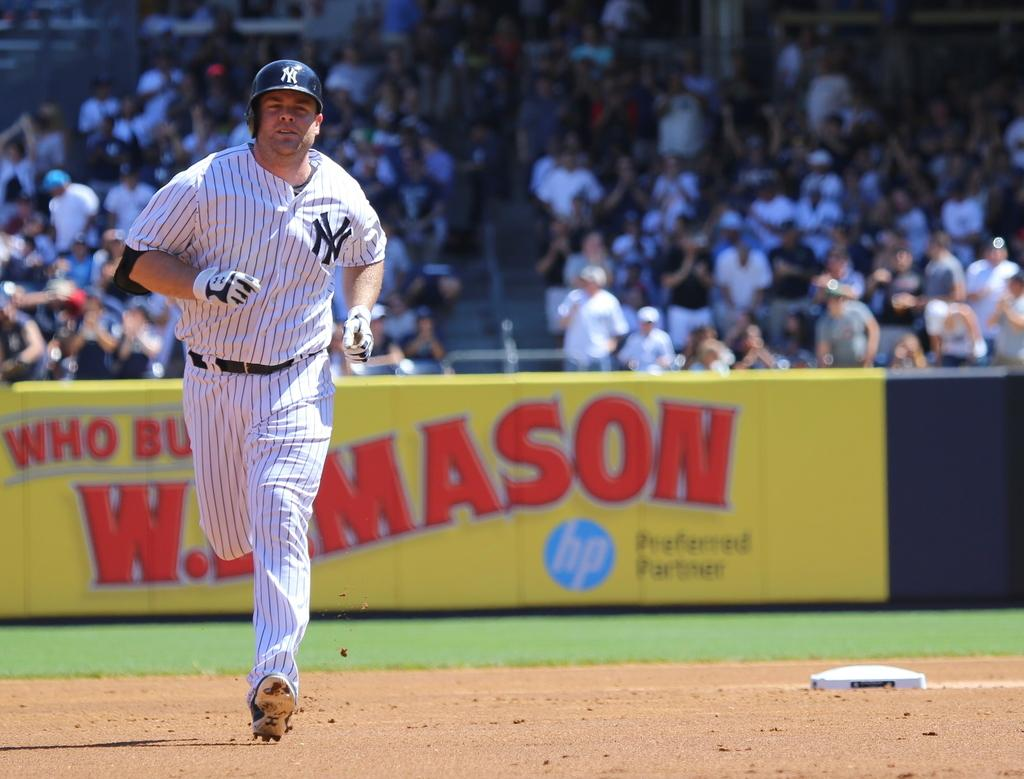<image>
Write a terse but informative summary of the picture. A New York player runs the bases during a baseball game. 